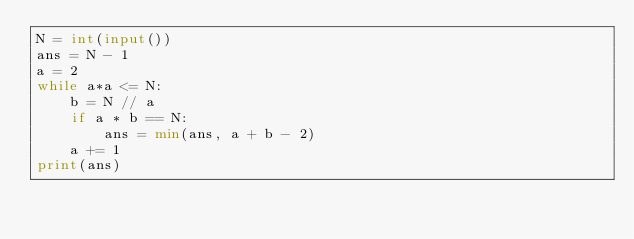Convert code to text. <code><loc_0><loc_0><loc_500><loc_500><_Python_>N = int(input())
ans = N - 1
a = 2
while a*a <= N:
    b = N // a
    if a * b == N:
        ans = min(ans, a + b - 2)
    a += 1
print(ans)</code> 